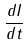<formula> <loc_0><loc_0><loc_500><loc_500>\frac { d I } { d t }</formula> 